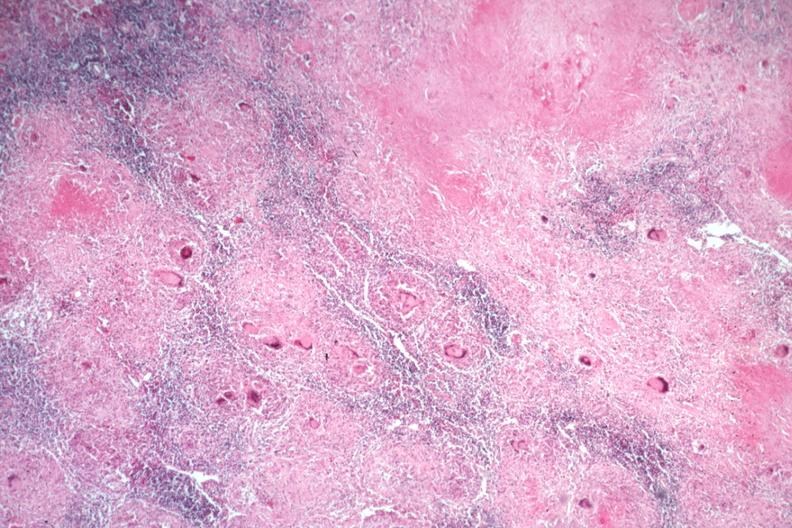s lymph node present?
Answer the question using a single word or phrase. Yes 